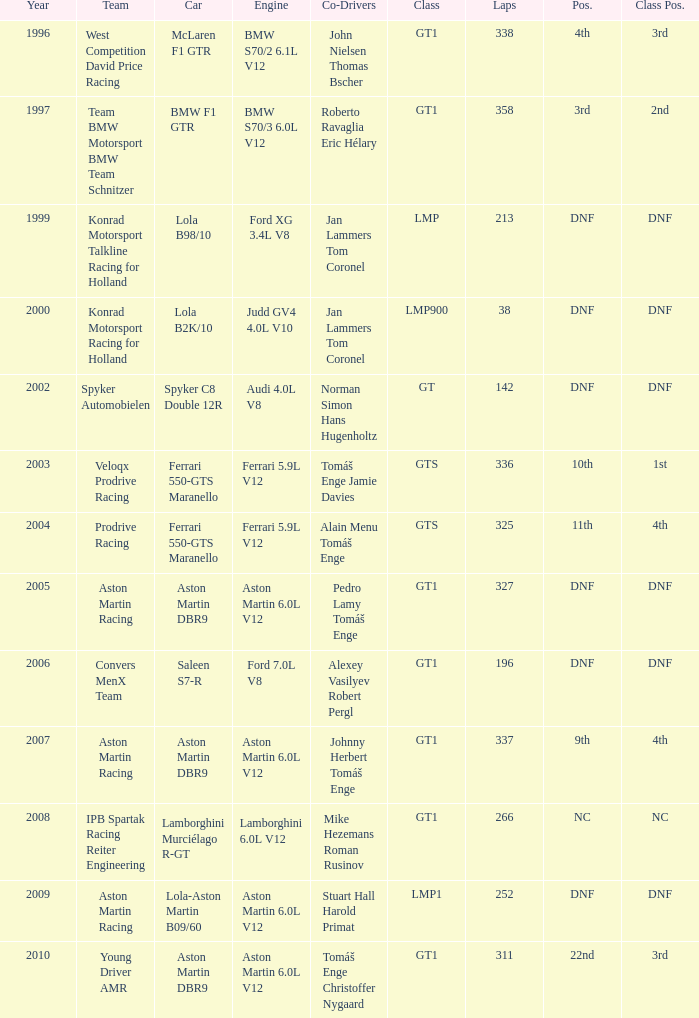Could you help me parse every detail presented in this table? {'header': ['Year', 'Team', 'Car', 'Engine', 'Co-Drivers', 'Class', 'Laps', 'Pos.', 'Class Pos.'], 'rows': [['1996', 'West Competition David Price Racing', 'McLaren F1 GTR', 'BMW S70/2 6.1L V12', 'John Nielsen Thomas Bscher', 'GT1', '338', '4th', '3rd'], ['1997', 'Team BMW Motorsport BMW Team Schnitzer', 'BMW F1 GTR', 'BMW S70/3 6.0L V12', 'Roberto Ravaglia Eric Hélary', 'GT1', '358', '3rd', '2nd'], ['1999', 'Konrad Motorsport Talkline Racing for Holland', 'Lola B98/10', 'Ford XG 3.4L V8', 'Jan Lammers Tom Coronel', 'LMP', '213', 'DNF', 'DNF'], ['2000', 'Konrad Motorsport Racing for Holland', 'Lola B2K/10', 'Judd GV4 4.0L V10', 'Jan Lammers Tom Coronel', 'LMP900', '38', 'DNF', 'DNF'], ['2002', 'Spyker Automobielen', 'Spyker C8 Double 12R', 'Audi 4.0L V8', 'Norman Simon Hans Hugenholtz', 'GT', '142', 'DNF', 'DNF'], ['2003', 'Veloqx Prodrive Racing', 'Ferrari 550-GTS Maranello', 'Ferrari 5.9L V12', 'Tomáš Enge Jamie Davies', 'GTS', '336', '10th', '1st'], ['2004', 'Prodrive Racing', 'Ferrari 550-GTS Maranello', 'Ferrari 5.9L V12', 'Alain Menu Tomáš Enge', 'GTS', '325', '11th', '4th'], ['2005', 'Aston Martin Racing', 'Aston Martin DBR9', 'Aston Martin 6.0L V12', 'Pedro Lamy Tomáš Enge', 'GT1', '327', 'DNF', 'DNF'], ['2006', 'Convers MenX Team', 'Saleen S7-R', 'Ford 7.0L V8', 'Alexey Vasilyev Robert Pergl', 'GT1', '196', 'DNF', 'DNF'], ['2007', 'Aston Martin Racing', 'Aston Martin DBR9', 'Aston Martin 6.0L V12', 'Johnny Herbert Tomáš Enge', 'GT1', '337', '9th', '4th'], ['2008', 'IPB Spartak Racing Reiter Engineering', 'Lamborghini Murciélago R-GT', 'Lamborghini 6.0L V12', 'Mike Hezemans Roman Rusinov', 'GT1', '266', 'NC', 'NC'], ['2009', 'Aston Martin Racing', 'Lola-Aston Martin B09/60', 'Aston Martin 6.0L V12', 'Stuart Hall Harold Primat', 'LMP1', '252', 'DNF', 'DNF'], ['2010', 'Young Driver AMR', 'Aston Martin DBR9', 'Aston Martin 6.0L V12', 'Tomáš Enge Christoffer Nygaard', 'GT1', '311', '22nd', '3rd']]} Which team finished 3rd in class with 337 laps before 2008? West Competition David Price Racing. 